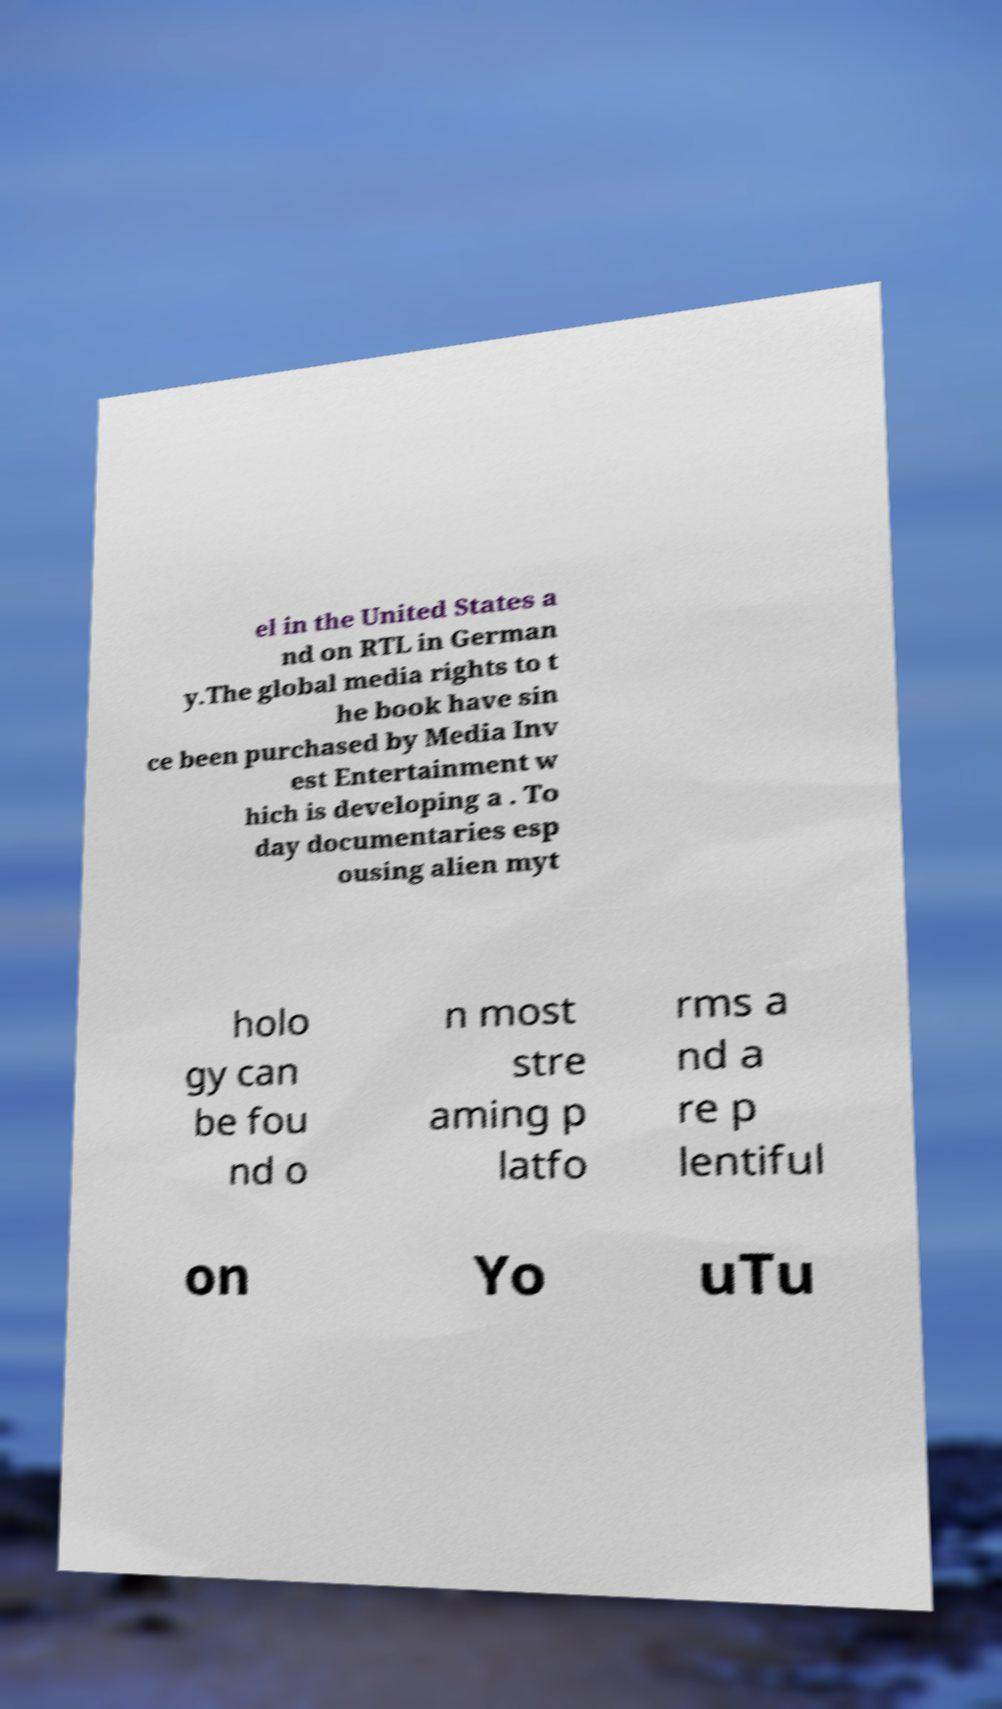Can you accurately transcribe the text from the provided image for me? el in the United States a nd on RTL in German y.The global media rights to t he book have sin ce been purchased by Media Inv est Entertainment w hich is developing a . To day documentaries esp ousing alien myt holo gy can be fou nd o n most stre aming p latfo rms a nd a re p lentiful on Yo uTu 